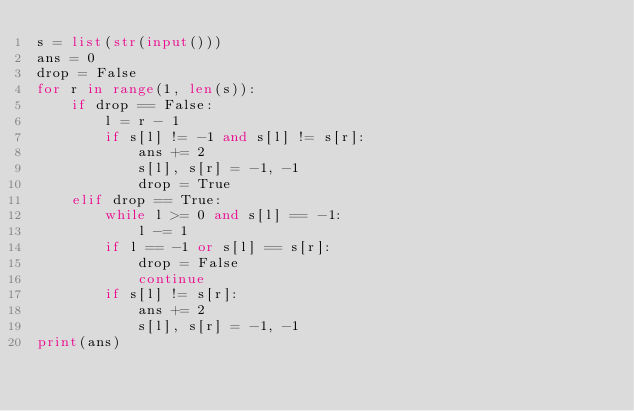<code> <loc_0><loc_0><loc_500><loc_500><_Python_>s = list(str(input()))
ans = 0
drop = False
for r in range(1, len(s)):
    if drop == False:
        l = r - 1
        if s[l] != -1 and s[l] != s[r]:
            ans += 2
            s[l], s[r] = -1, -1
            drop = True
    elif drop == True:
        while l >= 0 and s[l] == -1:
            l -= 1
        if l == -1 or s[l] == s[r]:
            drop = False
            continue
        if s[l] != s[r]:
            ans += 2
            s[l], s[r] = -1, -1
print(ans)</code> 